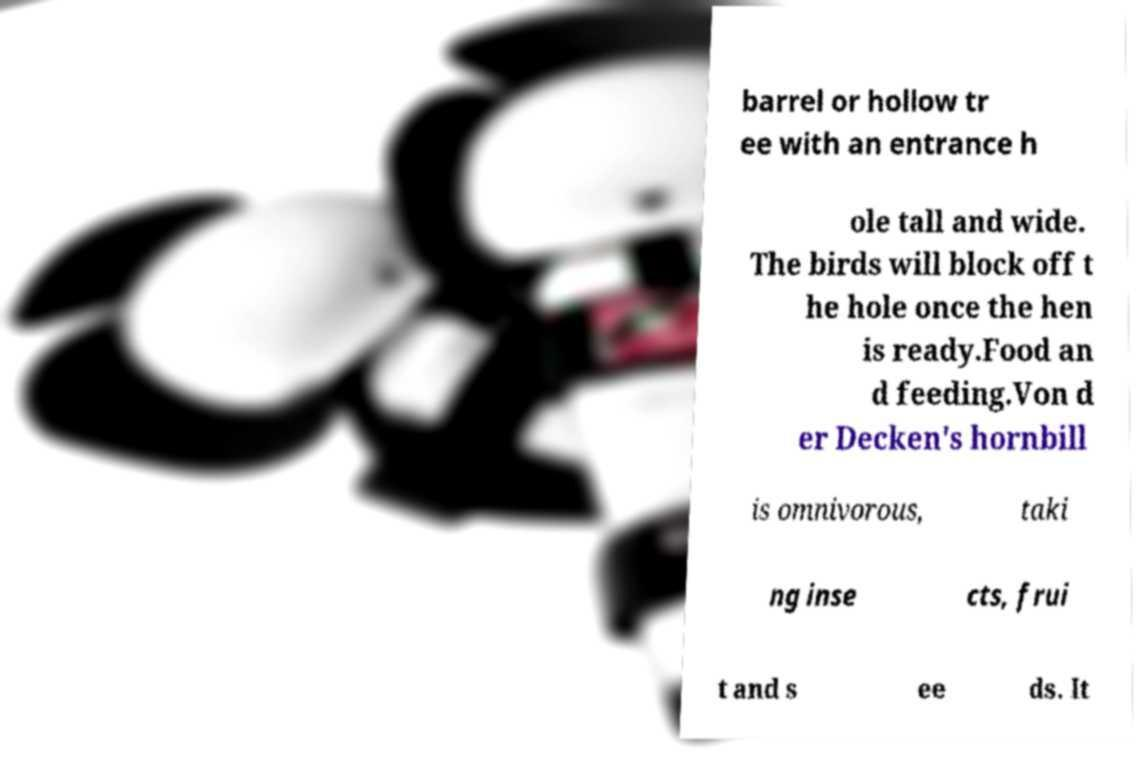What messages or text are displayed in this image? I need them in a readable, typed format. barrel or hollow tr ee with an entrance h ole tall and wide. The birds will block off t he hole once the hen is ready.Food an d feeding.Von d er Decken's hornbill is omnivorous, taki ng inse cts, frui t and s ee ds. It 